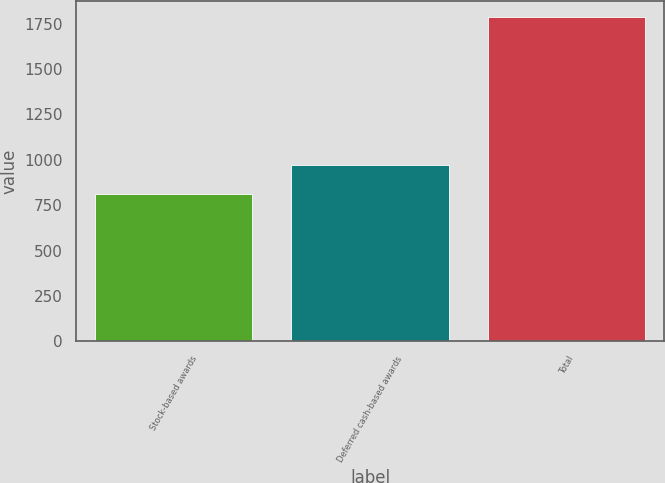Convert chart. <chart><loc_0><loc_0><loc_500><loc_500><bar_chart><fcel>Stock-based awards<fcel>Deferred cash-based awards<fcel>Total<nl><fcel>813<fcel>971<fcel>1784<nl></chart> 